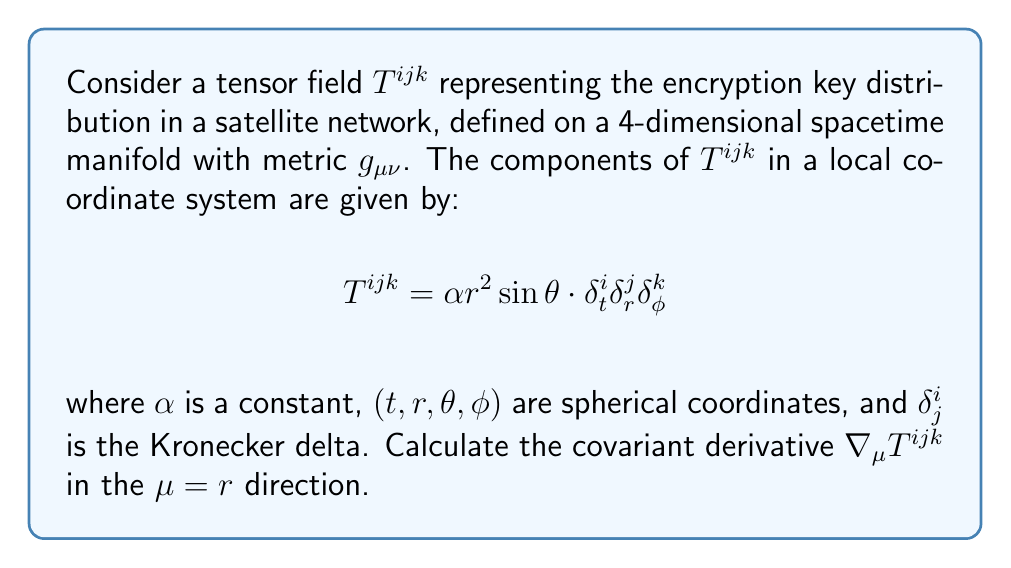Help me with this question. To evaluate the covariant derivative of the tensor $T^{ijk}$ in the $r$ direction, we need to follow these steps:

1) The general formula for the covariant derivative of a (3,0) tensor is:

   $$\nabla_\mu T^{ijk} = \partial_\mu T^{ijk} + \Gamma^i_{\mu\lambda}T^{\lambda jk} + \Gamma^j_{\mu\lambda}T^{i\lambda k} + \Gamma^k_{\mu\lambda}T^{ij\lambda}$$

   where $\Gamma^i_{\mu\lambda}$ are the Christoffel symbols.

2) For $\mu = r$, we have:

   $$\nabla_r T^{ijk} = \partial_r T^{ijk} + \Gamma^i_{r\lambda}T^{\lambda jk} + \Gamma^j_{r\lambda}T^{i\lambda k} + \Gamma^k_{r\lambda}T^{ij\lambda}$$

3) First, let's calculate $\partial_r T^{ijk}$:
   
   $$\partial_r T^{ijk} = \partial_r (\alpha r^2 \sin\theta \cdot \delta^i_t \delta^j_r \delta^k_\phi) = 2\alpha r \sin\theta \cdot \delta^i_t \delta^j_r \delta^k_\phi$$

4) Now, we need to consider the Christoffel symbol terms. In spherical coordinates, the non-zero Christoffel symbols involving $r$ are:

   $$\Gamma^r_{rr} = 0, \Gamma^{\theta}_{r\theta} = \Gamma^{\theta}_{\theta r} = \frac{1}{r}, \Gamma^{\phi}_{r\phi} = \Gamma^{\phi}_{\phi r} = \frac{1}{r}$$

5) Let's evaluate each Christoffel symbol term:

   - $\Gamma^i_{r\lambda}T^{\lambda jk}$: This is zero because $T^{\lambda jk}$ is non-zero only when $\lambda = t$, but $\Gamma^i_{rt} = 0$ for all $i$.
   
   - $\Gamma^j_{r\lambda}T^{i\lambda k}$: This is zero because $T^{i\lambda k}$ is non-zero only when $\lambda = r$, but $\Gamma^j_{rr} = 0$ for all $j$.
   
   - $\Gamma^k_{r\lambda}T^{ij\lambda}$: This is zero because $T^{ij\lambda}$ is non-zero only when $\lambda = \phi$, and $\Gamma^k_{r\phi} = 0$ for $k \neq \phi$. When $k = \phi$, we have $\Gamma^{\phi}_{r\phi}T^{ijr} = \frac{1}{r} \cdot 0 = 0$.

6) Therefore, all Christoffel symbol terms are zero, and we are left with only the partial derivative term:

   $$\nabla_r T^{ijk} = 2\alpha r \sin\theta \cdot \delta^i_t \delta^j_r \delta^k_\phi$$
Answer: $2\alpha r \sin\theta \cdot \delta^i_t \delta^j_r \delta^k_\phi$ 